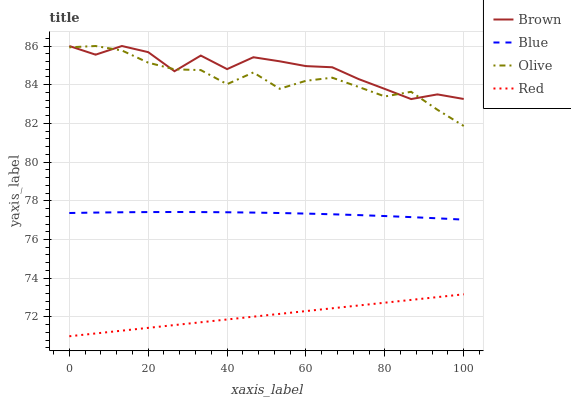Does Red have the minimum area under the curve?
Answer yes or no. Yes. Does Brown have the maximum area under the curve?
Answer yes or no. Yes. Does Brown have the minimum area under the curve?
Answer yes or no. No. Does Red have the maximum area under the curve?
Answer yes or no. No. Is Red the smoothest?
Answer yes or no. Yes. Is Brown the roughest?
Answer yes or no. Yes. Is Brown the smoothest?
Answer yes or no. No. Is Red the roughest?
Answer yes or no. No. Does Red have the lowest value?
Answer yes or no. Yes. Does Brown have the lowest value?
Answer yes or no. No. Does Olive have the highest value?
Answer yes or no. Yes. Does Red have the highest value?
Answer yes or no. No. Is Red less than Olive?
Answer yes or no. Yes. Is Brown greater than Blue?
Answer yes or no. Yes. Does Brown intersect Olive?
Answer yes or no. Yes. Is Brown less than Olive?
Answer yes or no. No. Is Brown greater than Olive?
Answer yes or no. No. Does Red intersect Olive?
Answer yes or no. No. 